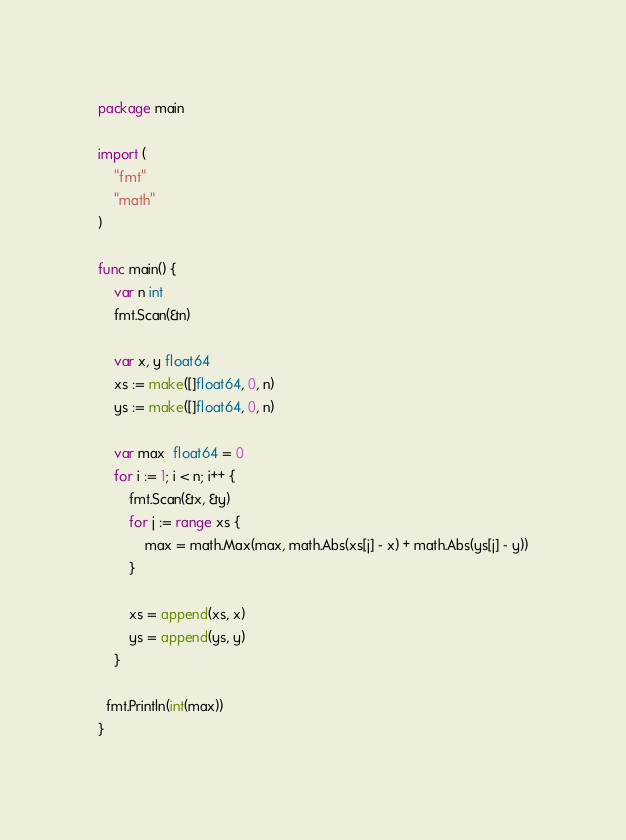Convert code to text. <code><loc_0><loc_0><loc_500><loc_500><_Go_>package main

import (
	"fmt"
	"math"
)

func main() {
	var n int
	fmt.Scan(&n)

	var x, y float64
	xs := make([]float64, 0, n)
	ys := make([]float64, 0, n)

	var max  float64 = 0
	for i := 1; i < n; i++ {
		fmt.Scan(&x, &y)
		for j := range xs {
			max = math.Max(max, math.Abs(xs[j] - x) + math.Abs(ys[j] - y))
		}

		xs = append(xs, x)
		ys = append(ys, y)
	}

  fmt.Println(int(max))
}</code> 